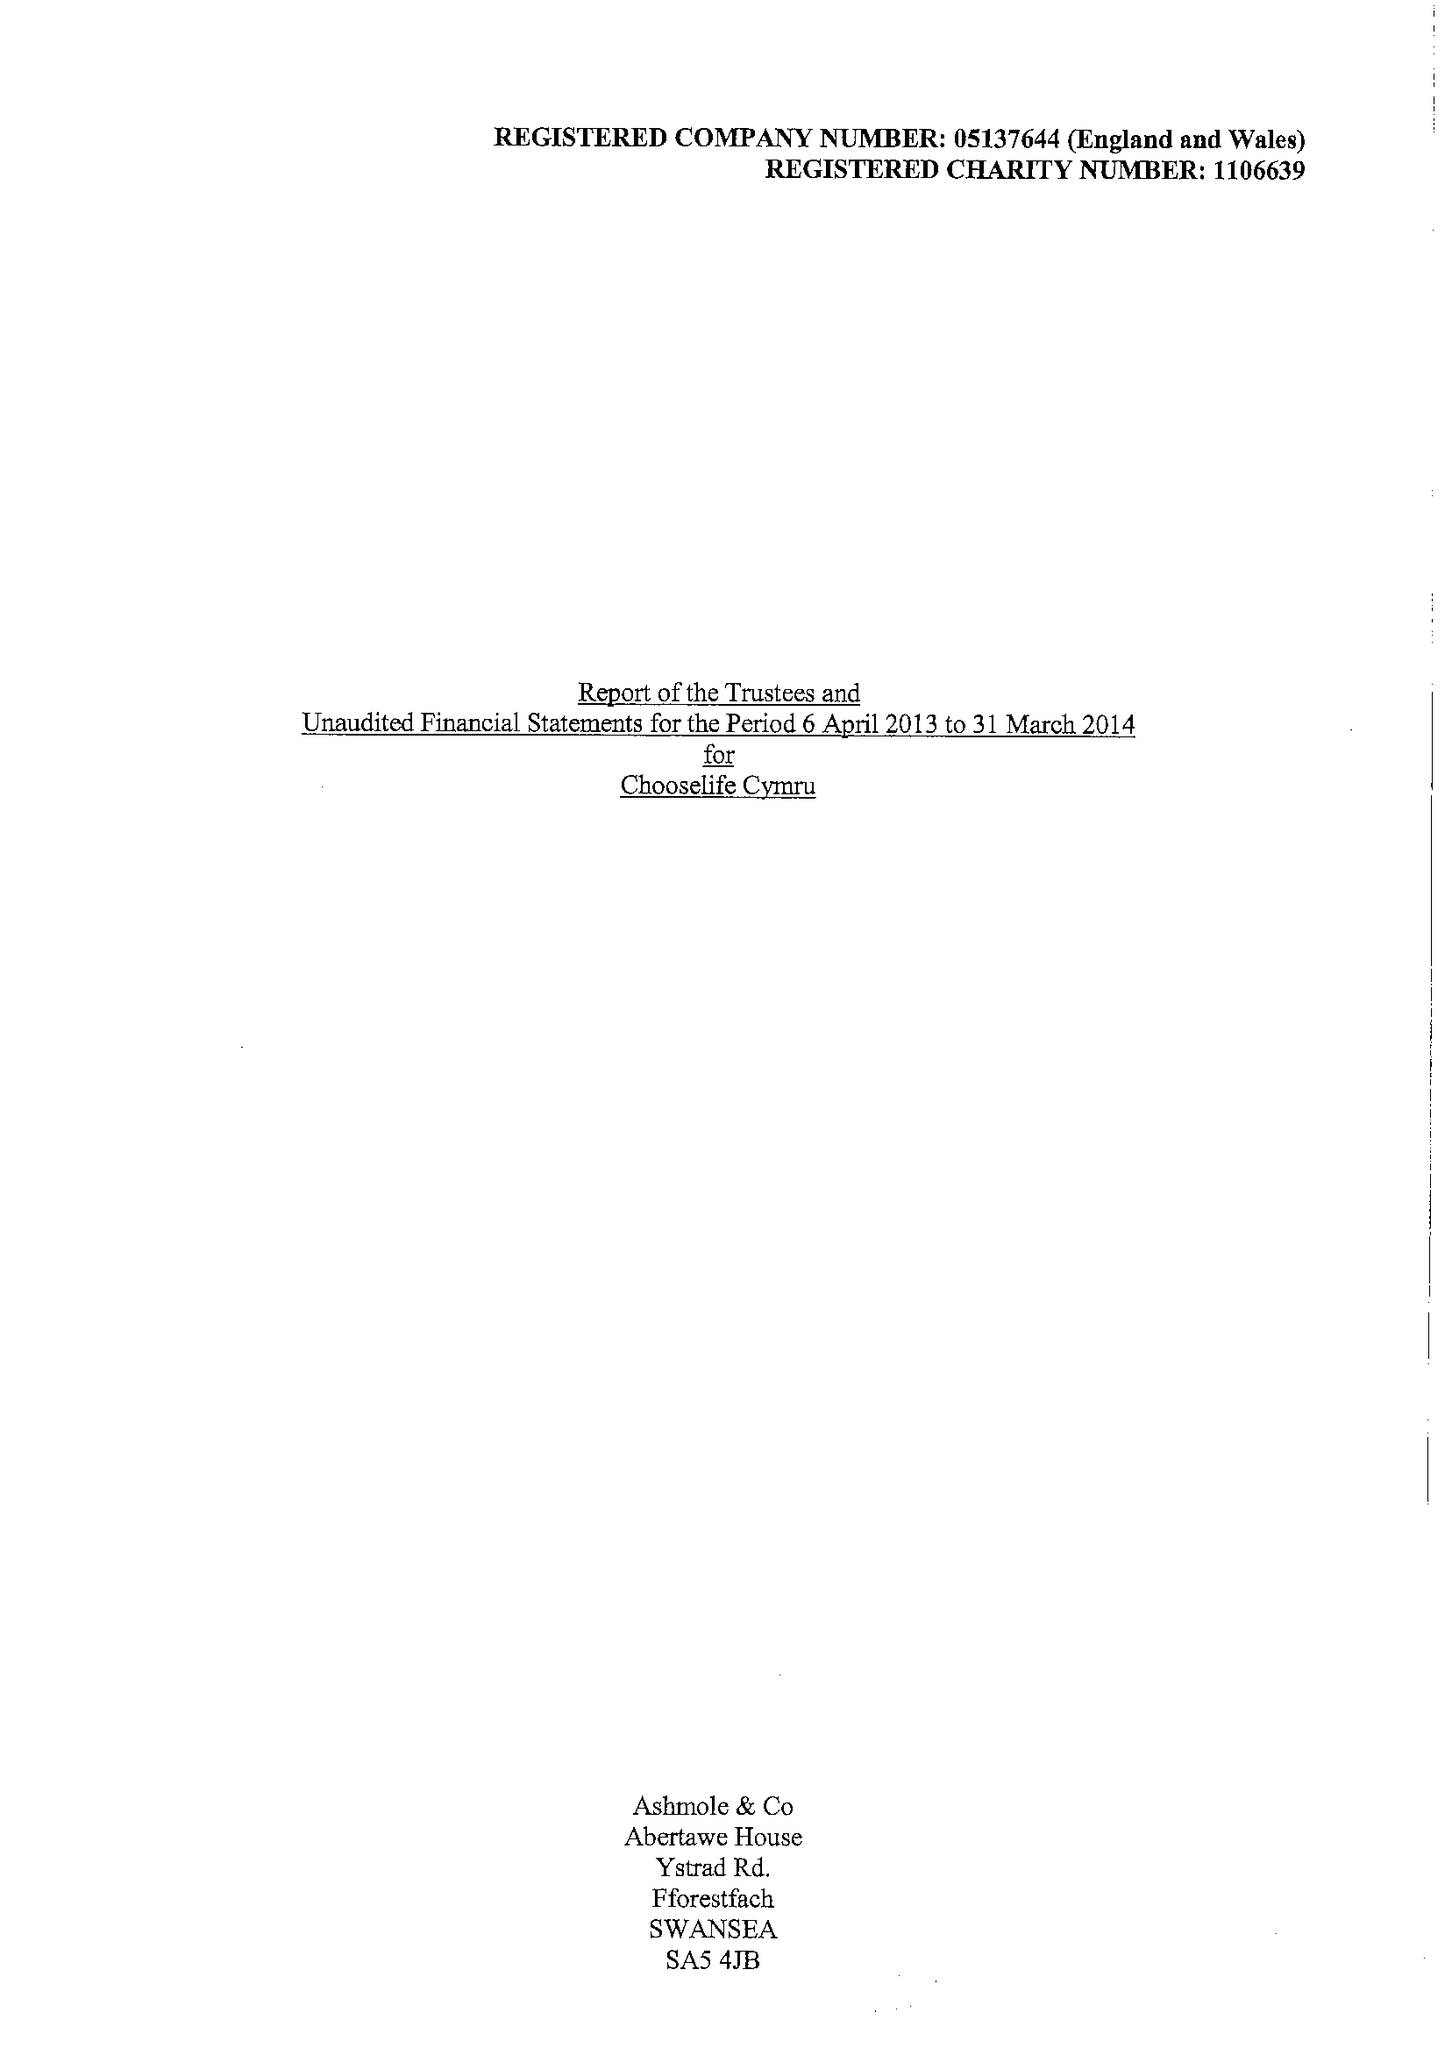What is the value for the charity_number?
Answer the question using a single word or phrase. 1106639 